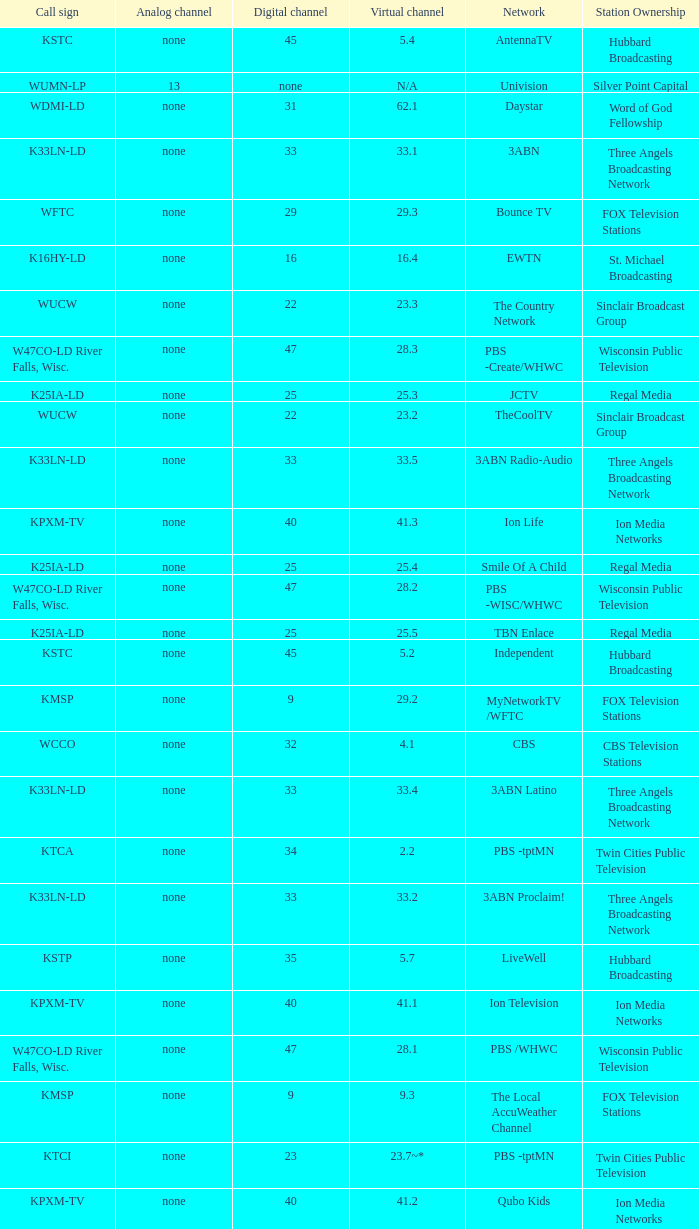Call sign of k33ln-ld, and a Virtual channel of 33.5 is what network? 3ABN Radio-Audio. Would you mind parsing the complete table? {'header': ['Call sign', 'Analog channel', 'Digital channel', 'Virtual channel', 'Network', 'Station Ownership'], 'rows': [['KSTC', 'none', '45', '5.4', 'AntennaTV', 'Hubbard Broadcasting'], ['WUMN-LP', '13', 'none', 'N/A', 'Univision', 'Silver Point Capital'], ['WDMI-LD', 'none', '31', '62.1', 'Daystar', 'Word of God Fellowship'], ['K33LN-LD', 'none', '33', '33.1', '3ABN', 'Three Angels Broadcasting Network'], ['WFTC', 'none', '29', '29.3', 'Bounce TV', 'FOX Television Stations'], ['K16HY-LD', 'none', '16', '16.4', 'EWTN', 'St. Michael Broadcasting'], ['WUCW', 'none', '22', '23.3', 'The Country Network', 'Sinclair Broadcast Group'], ['W47CO-LD River Falls, Wisc.', 'none', '47', '28.3', 'PBS -Create/WHWC', 'Wisconsin Public Television'], ['K25IA-LD', 'none', '25', '25.3', 'JCTV', 'Regal Media'], ['WUCW', 'none', '22', '23.2', 'TheCoolTV', 'Sinclair Broadcast Group'], ['K33LN-LD', 'none', '33', '33.5', '3ABN Radio-Audio', 'Three Angels Broadcasting Network'], ['KPXM-TV', 'none', '40', '41.3', 'Ion Life', 'Ion Media Networks'], ['K25IA-LD', 'none', '25', '25.4', 'Smile Of A Child', 'Regal Media'], ['W47CO-LD River Falls, Wisc.', 'none', '47', '28.2', 'PBS -WISC/WHWC', 'Wisconsin Public Television'], ['K25IA-LD', 'none', '25', '25.5', 'TBN Enlace', 'Regal Media'], ['KSTC', 'none', '45', '5.2', 'Independent', 'Hubbard Broadcasting'], ['KMSP', 'none', '9', '29.2', 'MyNetworkTV /WFTC', 'FOX Television Stations'], ['WCCO', 'none', '32', '4.1', 'CBS', 'CBS Television Stations'], ['K33LN-LD', 'none', '33', '33.4', '3ABN Latino', 'Three Angels Broadcasting Network'], ['KTCA', 'none', '34', '2.2', 'PBS -tptMN', 'Twin Cities Public Television'], ['K33LN-LD', 'none', '33', '33.2', '3ABN Proclaim!', 'Three Angels Broadcasting Network'], ['KSTP', 'none', '35', '5.7', 'LiveWell', 'Hubbard Broadcasting'], ['KPXM-TV', 'none', '40', '41.1', 'Ion Television', 'Ion Media Networks'], ['W47CO-LD River Falls, Wisc.', 'none', '47', '28.1', 'PBS /WHWC', 'Wisconsin Public Television'], ['KMSP', 'none', '9', '9.3', 'The Local AccuWeather Channel', 'FOX Television Stations'], ['KTCI', 'none', '23', '23.7~*', 'PBS -tptMN', 'Twin Cities Public Television'], ['KPXM-TV', 'none', '40', '41.2', 'Qubo Kids', 'Ion Media Networks'], ['KMSP', 'none', '9', '9.1', 'Fox', 'FOX Television Stations'], ['K25IA-LD', 'none', '25', '25.1', 'TBN', 'Regal Media'], ['K16HY-LD', 'none', '16', '16.3', 'Local Catholic', 'St. Michael Broadcasting'], ['KTCA', 'none', '34', '2.1', 'PBS -tpt', 'Twin Cities Public Television'], ['WUCW', 'none', '22', '23.1', 'CW', 'Sinclair Broadcast Group'], ['KTCI', 'none', '23', '2.3', 'PBS -tptLife', 'Twin Cities Public Television'], ['KARE', 'none', '11', '11.1', 'NBC', 'Gannett Company'], ['WFTC', 'none', '29', '29.4', 'Movies!', 'FOX Television Stations'], ['K19BG-LD St. Cloud/Buffalo', 'silent', '19CP', '19', 'RTV', 'Luken Communications'], ['KHVM-LD', 'none', '48', '48.1', 'GCN - Religious', 'EICB TV'], ['KTCJ-LD', 'none', '50', '50.1', 'CTVN - Religious', 'EICB TV'], ['K43HB-LD', 'none', '43', '43.1', 'HSN', 'Ventana Television'], ['WFTC', 'none', '29', '9.2', 'MyNetworkTV /WFTC', 'FOX Television Stations'], ['WFTC', 'none', '29', '29.1', 'MyNetworkTV', 'FOX Television Stations'], ['KARE', 'none', '11', '11.2', 'WeatherNation TV', 'Gannett Company'], ['K16HY-LD', 'none', '16', '16.2', 'EWTN', 'St. Michael Broadcasting'], ['K25IA-LD', 'none', '25', '25.2', 'The Church Channel', 'Regal Media'], ['KSTC', 'none', '45', '5.6', 'ThisTV', 'Hubbard Broadcasting'], ['K16HY-LD', 'none', '16', '16.5', 'EWTN', 'St. Michael Broadcasting'], ['K33LN-LD', 'none', '33', '33.6', '3ABN Radio Latino-Audio', 'Three Angels Broadcasting Network'], ['KSTC', 'none', '45', '5.3', 'MeTV', 'Hubbard Broadcasting'], ['KTCA', 'none', '34', '2.4', 'PBS -tptWx', 'Twin Cities Public Television'], ['K16HY-LD', 'none', '16', '16.1', 'Local Catholic-Text', 'St. Michael Broadcasting'], ['KSTP', 'none', '35', '5.1', 'ABC', 'Hubbard Broadcasting'], ['K33LN-LD', 'none', '33', '33.7', 'Radio 74-Audio', 'Three Angels Broadcasting Network'], ['K33LN-LD', 'none', '33', '33.3', '3ABN Dare to Dream', 'Three Angels Broadcasting Network']]} 